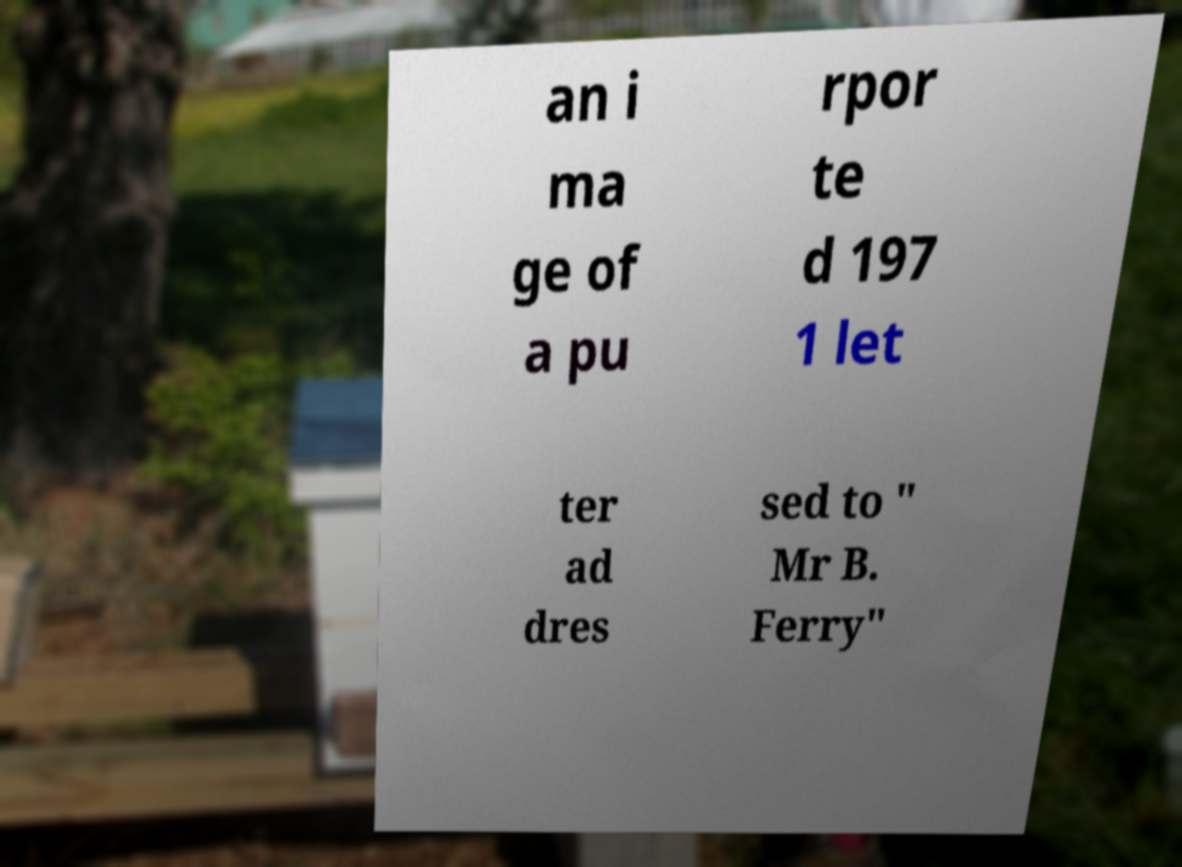Please read and relay the text visible in this image. What does it say? an i ma ge of a pu rpor te d 197 1 let ter ad dres sed to " Mr B. Ferry" 